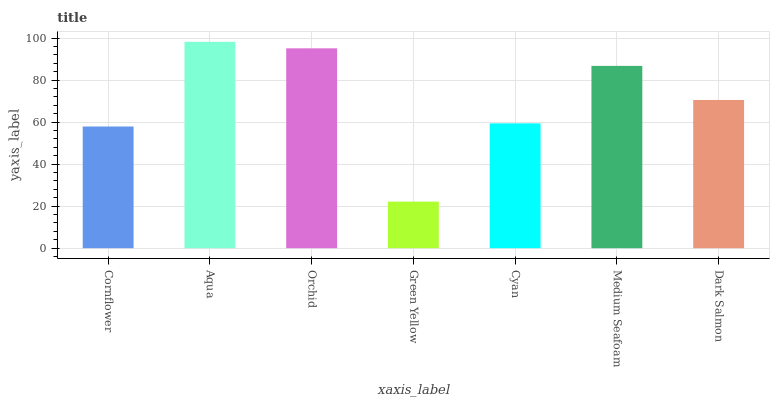Is Green Yellow the minimum?
Answer yes or no. Yes. Is Aqua the maximum?
Answer yes or no. Yes. Is Orchid the minimum?
Answer yes or no. No. Is Orchid the maximum?
Answer yes or no. No. Is Aqua greater than Orchid?
Answer yes or no. Yes. Is Orchid less than Aqua?
Answer yes or no. Yes. Is Orchid greater than Aqua?
Answer yes or no. No. Is Aqua less than Orchid?
Answer yes or no. No. Is Dark Salmon the high median?
Answer yes or no. Yes. Is Dark Salmon the low median?
Answer yes or no. Yes. Is Medium Seafoam the high median?
Answer yes or no. No. Is Green Yellow the low median?
Answer yes or no. No. 